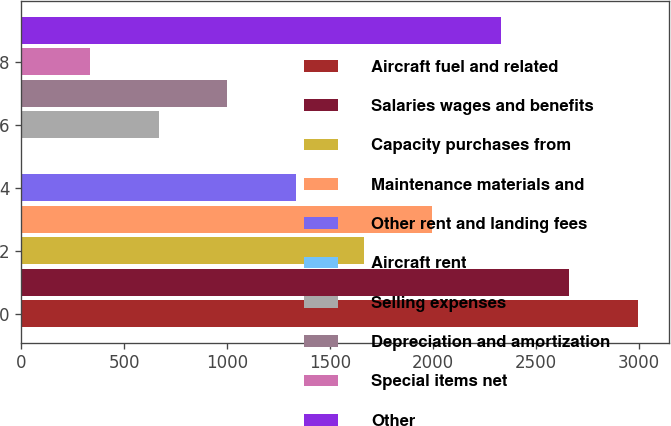<chart> <loc_0><loc_0><loc_500><loc_500><bar_chart><fcel>Aircraft fuel and related<fcel>Salaries wages and benefits<fcel>Capacity purchases from<fcel>Maintenance materials and<fcel>Other rent and landing fees<fcel>Aircraft rent<fcel>Selling expenses<fcel>Depreciation and amortization<fcel>Special items net<fcel>Other<nl><fcel>2993.8<fcel>2661.6<fcel>1665<fcel>1997.2<fcel>1332.8<fcel>4<fcel>668.4<fcel>1000.6<fcel>336.2<fcel>2329.4<nl></chart> 